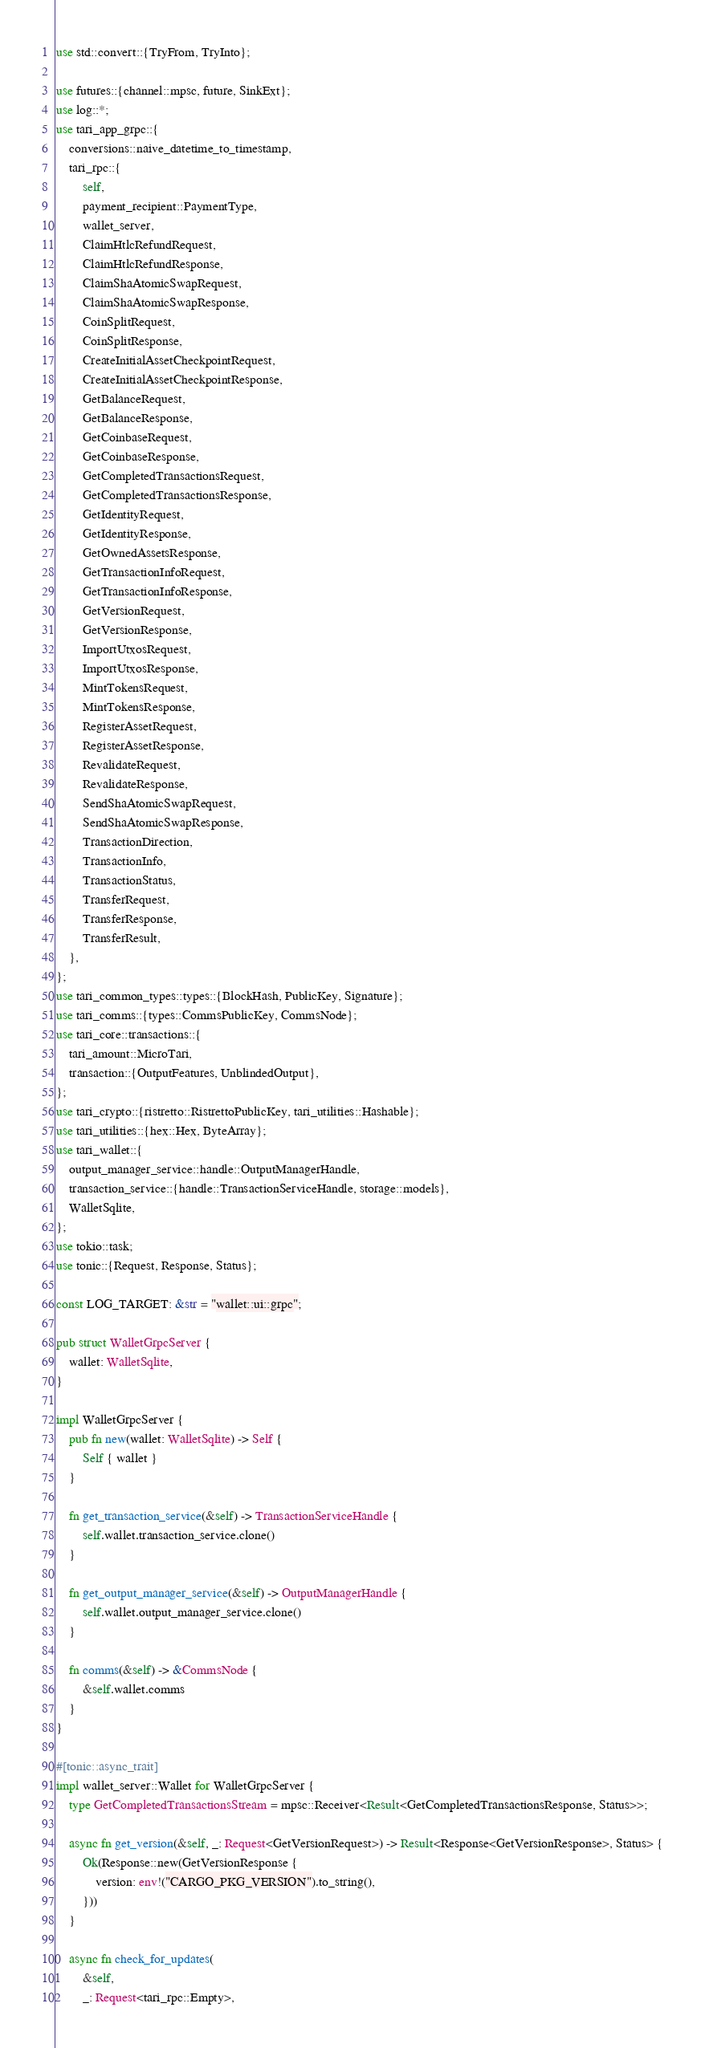Convert code to text. <code><loc_0><loc_0><loc_500><loc_500><_Rust_>use std::convert::{TryFrom, TryInto};

use futures::{channel::mpsc, future, SinkExt};
use log::*;
use tari_app_grpc::{
    conversions::naive_datetime_to_timestamp,
    tari_rpc::{
        self,
        payment_recipient::PaymentType,
        wallet_server,
        ClaimHtlcRefundRequest,
        ClaimHtlcRefundResponse,
        ClaimShaAtomicSwapRequest,
        ClaimShaAtomicSwapResponse,
        CoinSplitRequest,
        CoinSplitResponse,
        CreateInitialAssetCheckpointRequest,
        CreateInitialAssetCheckpointResponse,
        GetBalanceRequest,
        GetBalanceResponse,
        GetCoinbaseRequest,
        GetCoinbaseResponse,
        GetCompletedTransactionsRequest,
        GetCompletedTransactionsResponse,
        GetIdentityRequest,
        GetIdentityResponse,
        GetOwnedAssetsResponse,
        GetTransactionInfoRequest,
        GetTransactionInfoResponse,
        GetVersionRequest,
        GetVersionResponse,
        ImportUtxosRequest,
        ImportUtxosResponse,
        MintTokensRequest,
        MintTokensResponse,
        RegisterAssetRequest,
        RegisterAssetResponse,
        RevalidateRequest,
        RevalidateResponse,
        SendShaAtomicSwapRequest,
        SendShaAtomicSwapResponse,
        TransactionDirection,
        TransactionInfo,
        TransactionStatus,
        TransferRequest,
        TransferResponse,
        TransferResult,
    },
};
use tari_common_types::types::{BlockHash, PublicKey, Signature};
use tari_comms::{types::CommsPublicKey, CommsNode};
use tari_core::transactions::{
    tari_amount::MicroTari,
    transaction::{OutputFeatures, UnblindedOutput},
};
use tari_crypto::{ristretto::RistrettoPublicKey, tari_utilities::Hashable};
use tari_utilities::{hex::Hex, ByteArray};
use tari_wallet::{
    output_manager_service::handle::OutputManagerHandle,
    transaction_service::{handle::TransactionServiceHandle, storage::models},
    WalletSqlite,
};
use tokio::task;
use tonic::{Request, Response, Status};

const LOG_TARGET: &str = "wallet::ui::grpc";

pub struct WalletGrpcServer {
    wallet: WalletSqlite,
}

impl WalletGrpcServer {
    pub fn new(wallet: WalletSqlite) -> Self {
        Self { wallet }
    }

    fn get_transaction_service(&self) -> TransactionServiceHandle {
        self.wallet.transaction_service.clone()
    }

    fn get_output_manager_service(&self) -> OutputManagerHandle {
        self.wallet.output_manager_service.clone()
    }

    fn comms(&self) -> &CommsNode {
        &self.wallet.comms
    }
}

#[tonic::async_trait]
impl wallet_server::Wallet for WalletGrpcServer {
    type GetCompletedTransactionsStream = mpsc::Receiver<Result<GetCompletedTransactionsResponse, Status>>;

    async fn get_version(&self, _: Request<GetVersionRequest>) -> Result<Response<GetVersionResponse>, Status> {
        Ok(Response::new(GetVersionResponse {
            version: env!("CARGO_PKG_VERSION").to_string(),
        }))
    }

    async fn check_for_updates(
        &self,
        _: Request<tari_rpc::Empty>,</code> 